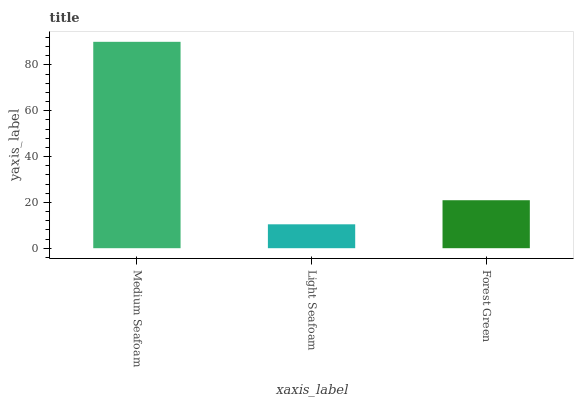Is Light Seafoam the minimum?
Answer yes or no. Yes. Is Medium Seafoam the maximum?
Answer yes or no. Yes. Is Forest Green the minimum?
Answer yes or no. No. Is Forest Green the maximum?
Answer yes or no. No. Is Forest Green greater than Light Seafoam?
Answer yes or no. Yes. Is Light Seafoam less than Forest Green?
Answer yes or no. Yes. Is Light Seafoam greater than Forest Green?
Answer yes or no. No. Is Forest Green less than Light Seafoam?
Answer yes or no. No. Is Forest Green the high median?
Answer yes or no. Yes. Is Forest Green the low median?
Answer yes or no. Yes. Is Light Seafoam the high median?
Answer yes or no. No. Is Medium Seafoam the low median?
Answer yes or no. No. 